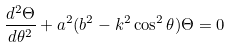Convert formula to latex. <formula><loc_0><loc_0><loc_500><loc_500>\frac { d ^ { 2 } \Theta } { d \theta ^ { 2 } } + a ^ { 2 } ( b ^ { 2 } - k ^ { 2 } \cos ^ { 2 } \theta ) \Theta = 0</formula> 